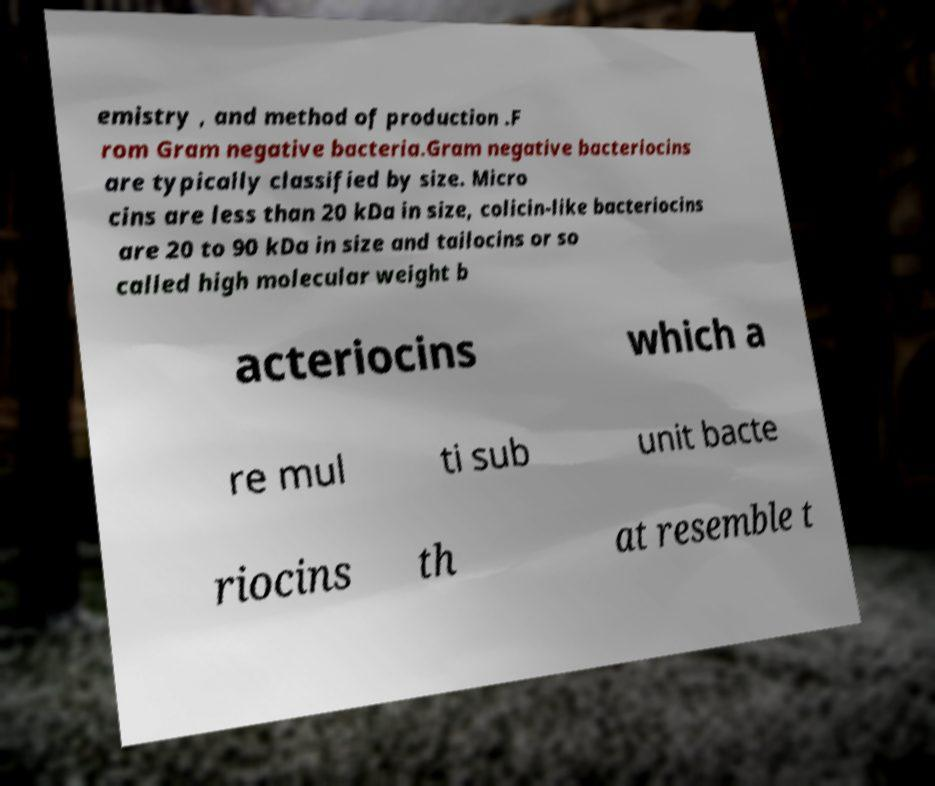Can you accurately transcribe the text from the provided image for me? emistry , and method of production .F rom Gram negative bacteria.Gram negative bacteriocins are typically classified by size. Micro cins are less than 20 kDa in size, colicin-like bacteriocins are 20 to 90 kDa in size and tailocins or so called high molecular weight b acteriocins which a re mul ti sub unit bacte riocins th at resemble t 